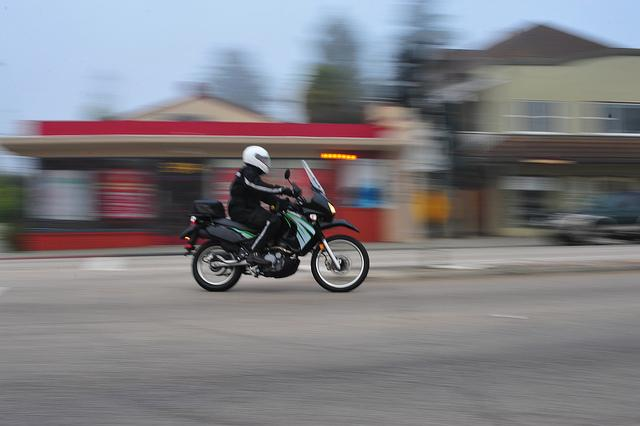Why is the man wearing a white helmet? protection 